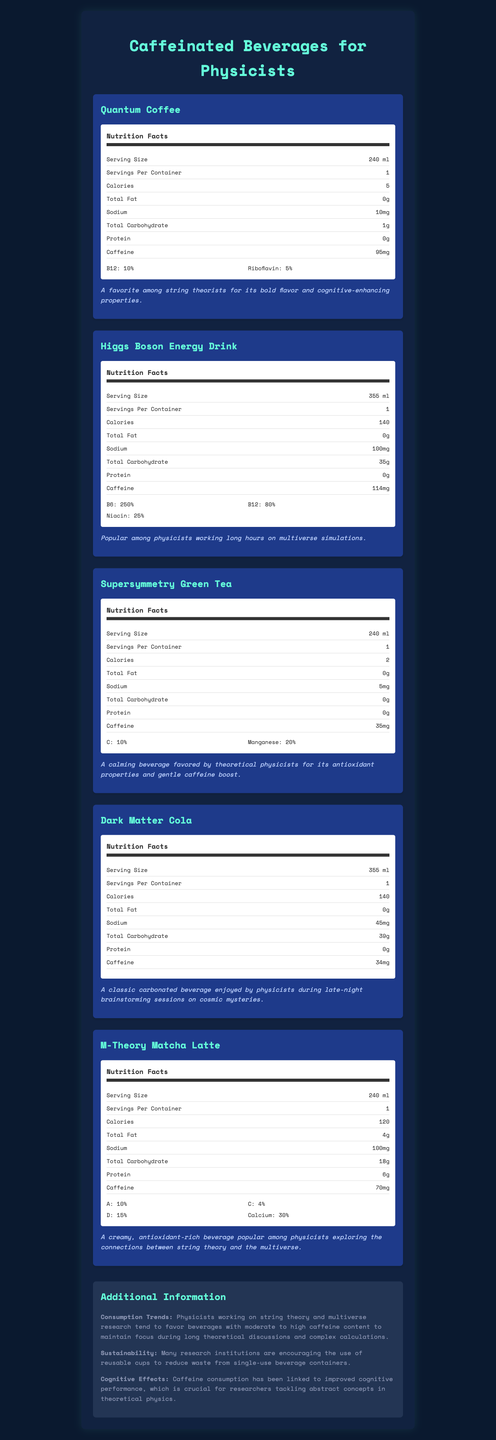what is the serving size of Quantum Coffee? The document states that the serving size of Quantum Coffee is 240 ml.
Answer: 240 ml which beverage has the highest caffeine content? A. Quantum Coffee B. Higgs Boson Energy Drink C. Supersymmetry Green Tea D. Dark Matter Cola E. M-Theory Matcha Latte The document shows that Higgs Boson Energy Drink has 114 mg of caffeine, which is the highest among the listed beverages.
Answer: B How many milligrams of sodium does Dark Matter Cola contain? According to the nutrition facts, Dark Matter Cola contains 45 mg of sodium.
Answer: 45 mg Does Supersymmetry Green Tea have more caffeine than Dark Matter Cola? Supersymmetry Green Tea has 35 mg of caffeine, while Dark Matter Cola has 34 mg, making the former slightly higher in caffeine content.
Answer: Yes Which beverage offers the highest percentage of Vitamin B12 in its serving? A. Quantum Coffee B. Higgs Boson Energy Drink C. Supersymmetry Green Tea D. Dark Matter Cola E. M-Theory Matcha Latte Higgs Boson Energy Drink contains 80% of Vitamin B12 per serving, while Quantum Coffee has 10%.
Answer: B Do any of the listed beverages contain protein? M-Theory Matcha Latte contains 6 grams of protein per serving.
Answer: Yes What are the cognitive benefits linked to caffeine consumption mentioned in the additional information? The document specifies that caffeine consumption has been linked to improved cognitive performance.
Answer: Improved cognitive performance List the vitamins available in Quantum Coffee. The nutrition label for Quantum Coffee shows it contains Vitamin B12 and Riboflavin.
Answer: B12, Riboflavin Between all beverages, which one has the least number of calories per serving? Supersymmetry Green Tea has 2 calories per serving, the least among all listed beverages.
Answer: Supersymmetry Green Tea Summarize the main purpose of the document. The summary of the document captures its aim to compare nutrient content of caffeinated beverages relevant to physicists, detailing their nutritional values and adding context on their usage and benefits.
Answer: The document provides a detailed comparison of the nutrient content in various caffeinated beverages popular among physicists, including serving size, calories, caffeine content, and vitamin percentages. It also includes additional information on consumption trends, sustainability, and cognitive effects of caffeine. Why do physicists working on theoretical concepts prefer moderate to high caffeine beverages? The additional information section mentions that physicists favor moderate to high caffeine beverages to maintain focus during extensive theoretical discussions and complex calculations.
Answer: To maintain focus during long theoretical discussions and complex calculations. What is the total carbohydrate content in M-Theory Matcha Latte? The document states that M-Theory Matcha Latte has 18 grams of total carbohydrate per serving.
Answer: 18 g Which beverage contains Vitamin A and what percentage? The nutrition label for M-Theory Matcha Latte shows it contains 10% of Vitamin A.
Answer: M-Theory Matcha Latte, 10% How much caffeine is in a serving of Dark Matter Cola? According to the nutrition label, Dark Matter Cola has 34 mg of caffeine per serving.
Answer: 34 mg Does the document provide the cost of each beverage? The document does not include any pricing details for the beverages.
Answer: Not enough information 